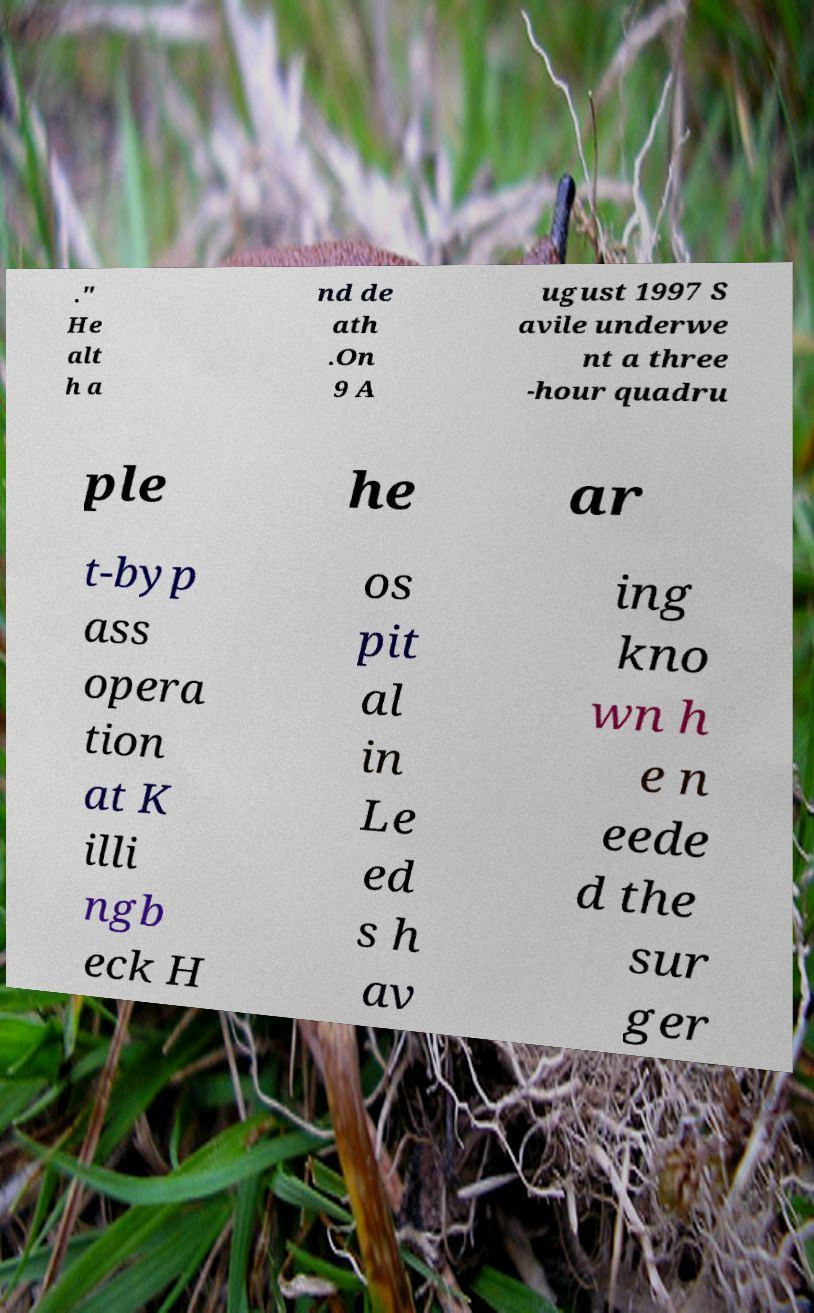Can you read and provide the text displayed in the image?This photo seems to have some interesting text. Can you extract and type it out for me? ." He alt h a nd de ath .On 9 A ugust 1997 S avile underwe nt a three -hour quadru ple he ar t-byp ass opera tion at K illi ngb eck H os pit al in Le ed s h av ing kno wn h e n eede d the sur ger 